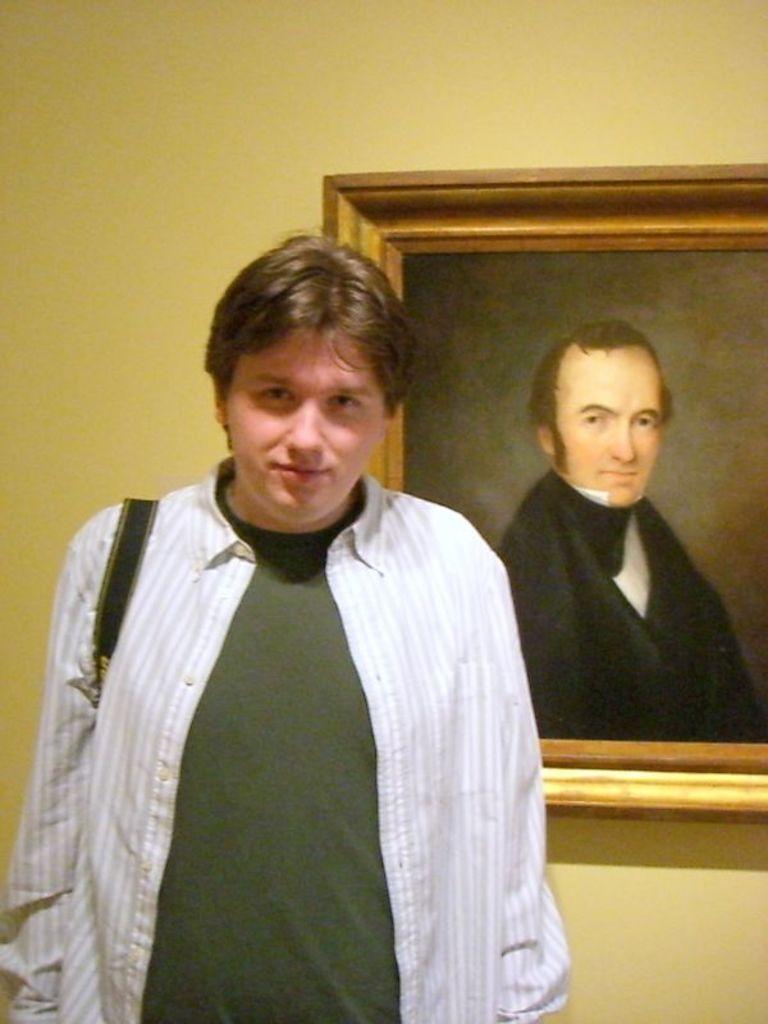Please provide a concise description of this image. In the foreground we can see a person, he is standing. On the right there is a frame attached to the wall. In the background there is wall. 